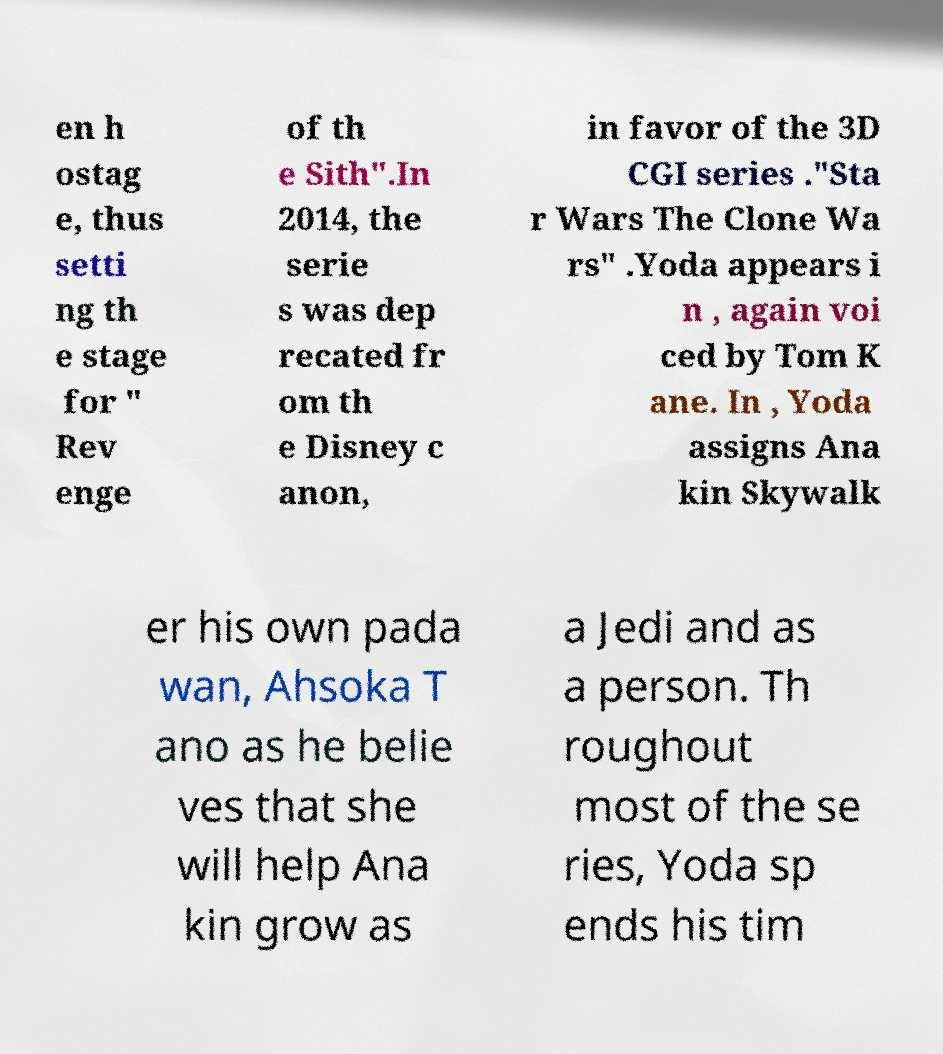Can you accurately transcribe the text from the provided image for me? en h ostag e, thus setti ng th e stage for " Rev enge of th e Sith".In 2014, the serie s was dep recated fr om th e Disney c anon, in favor of the 3D CGI series ."Sta r Wars The Clone Wa rs" .Yoda appears i n , again voi ced by Tom K ane. In , Yoda assigns Ana kin Skywalk er his own pada wan, Ahsoka T ano as he belie ves that she will help Ana kin grow as a Jedi and as a person. Th roughout most of the se ries, Yoda sp ends his tim 